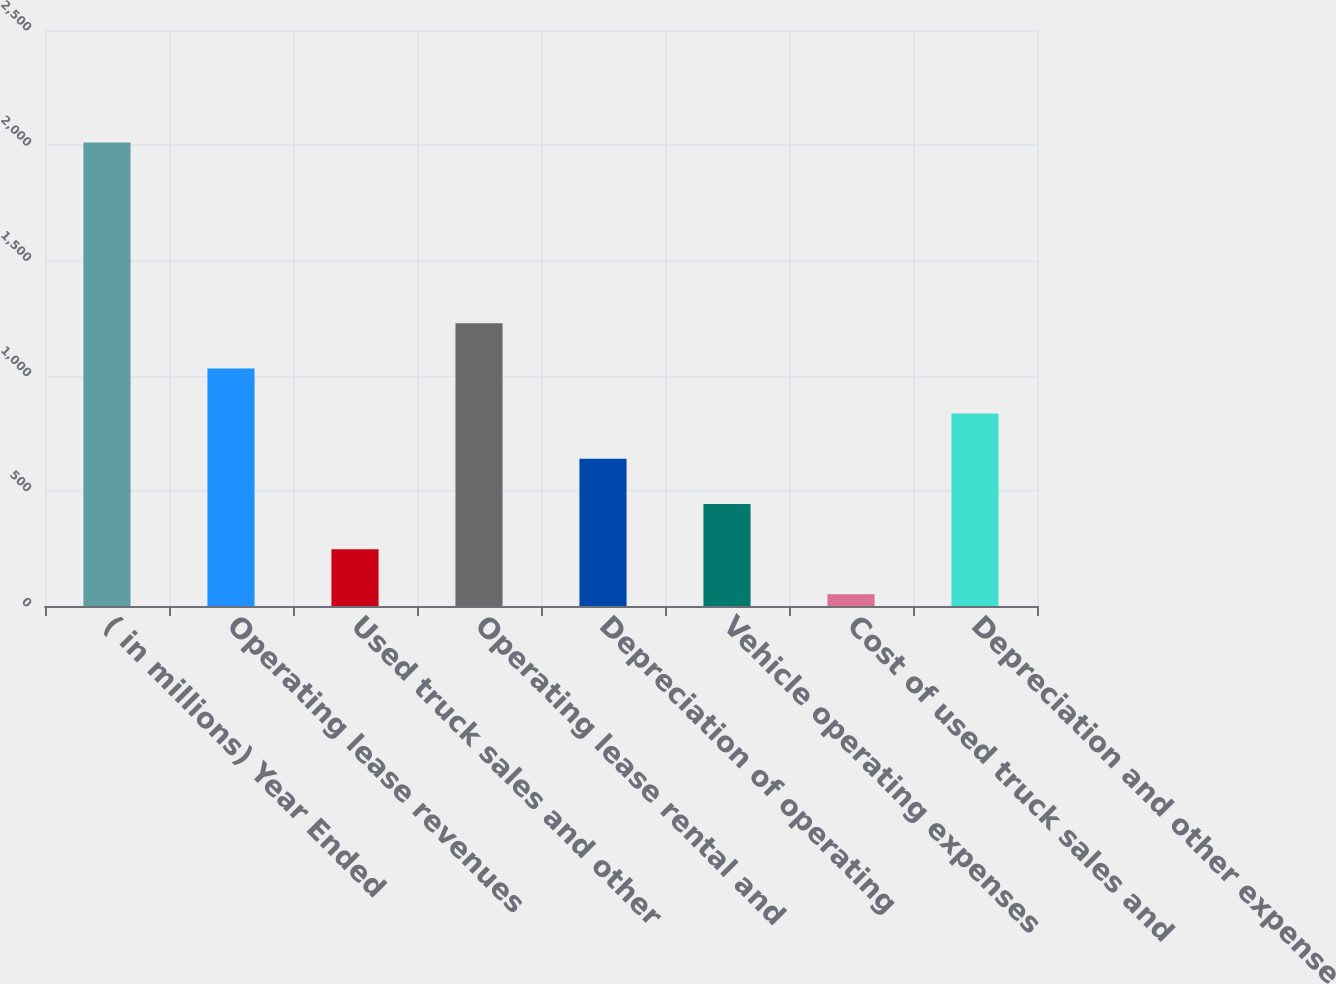Convert chart. <chart><loc_0><loc_0><loc_500><loc_500><bar_chart><fcel>( in millions) Year Ended<fcel>Operating lease revenues<fcel>Used truck sales and other<fcel>Operating lease rental and<fcel>Depreciation of operating<fcel>Vehicle operating expenses<fcel>Cost of used truck sales and<fcel>Depreciation and other expense<nl><fcel>2012<fcel>1031.25<fcel>246.65<fcel>1227.4<fcel>638.95<fcel>442.8<fcel>50.5<fcel>835.1<nl></chart> 